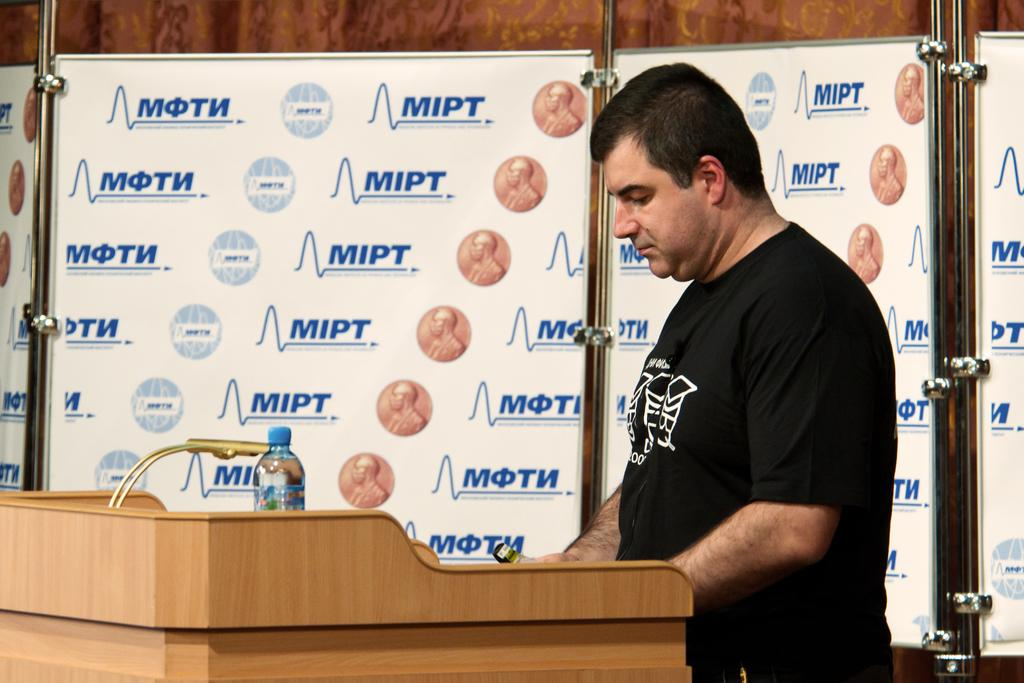What is the man in the image doing? The man is standing next to a podium in the image. What object is visible near the man? There is a water bottle in the image. What can be seen in the background of the image? There are whiteboards in the background of the image. What is written on the whiteboards? The acronym "MIPT" is written on the whiteboards. Can you see any boats in the image? No, there are no boats present in the image. Is there a farmer in the image? No, there is no farmer present in the image. 